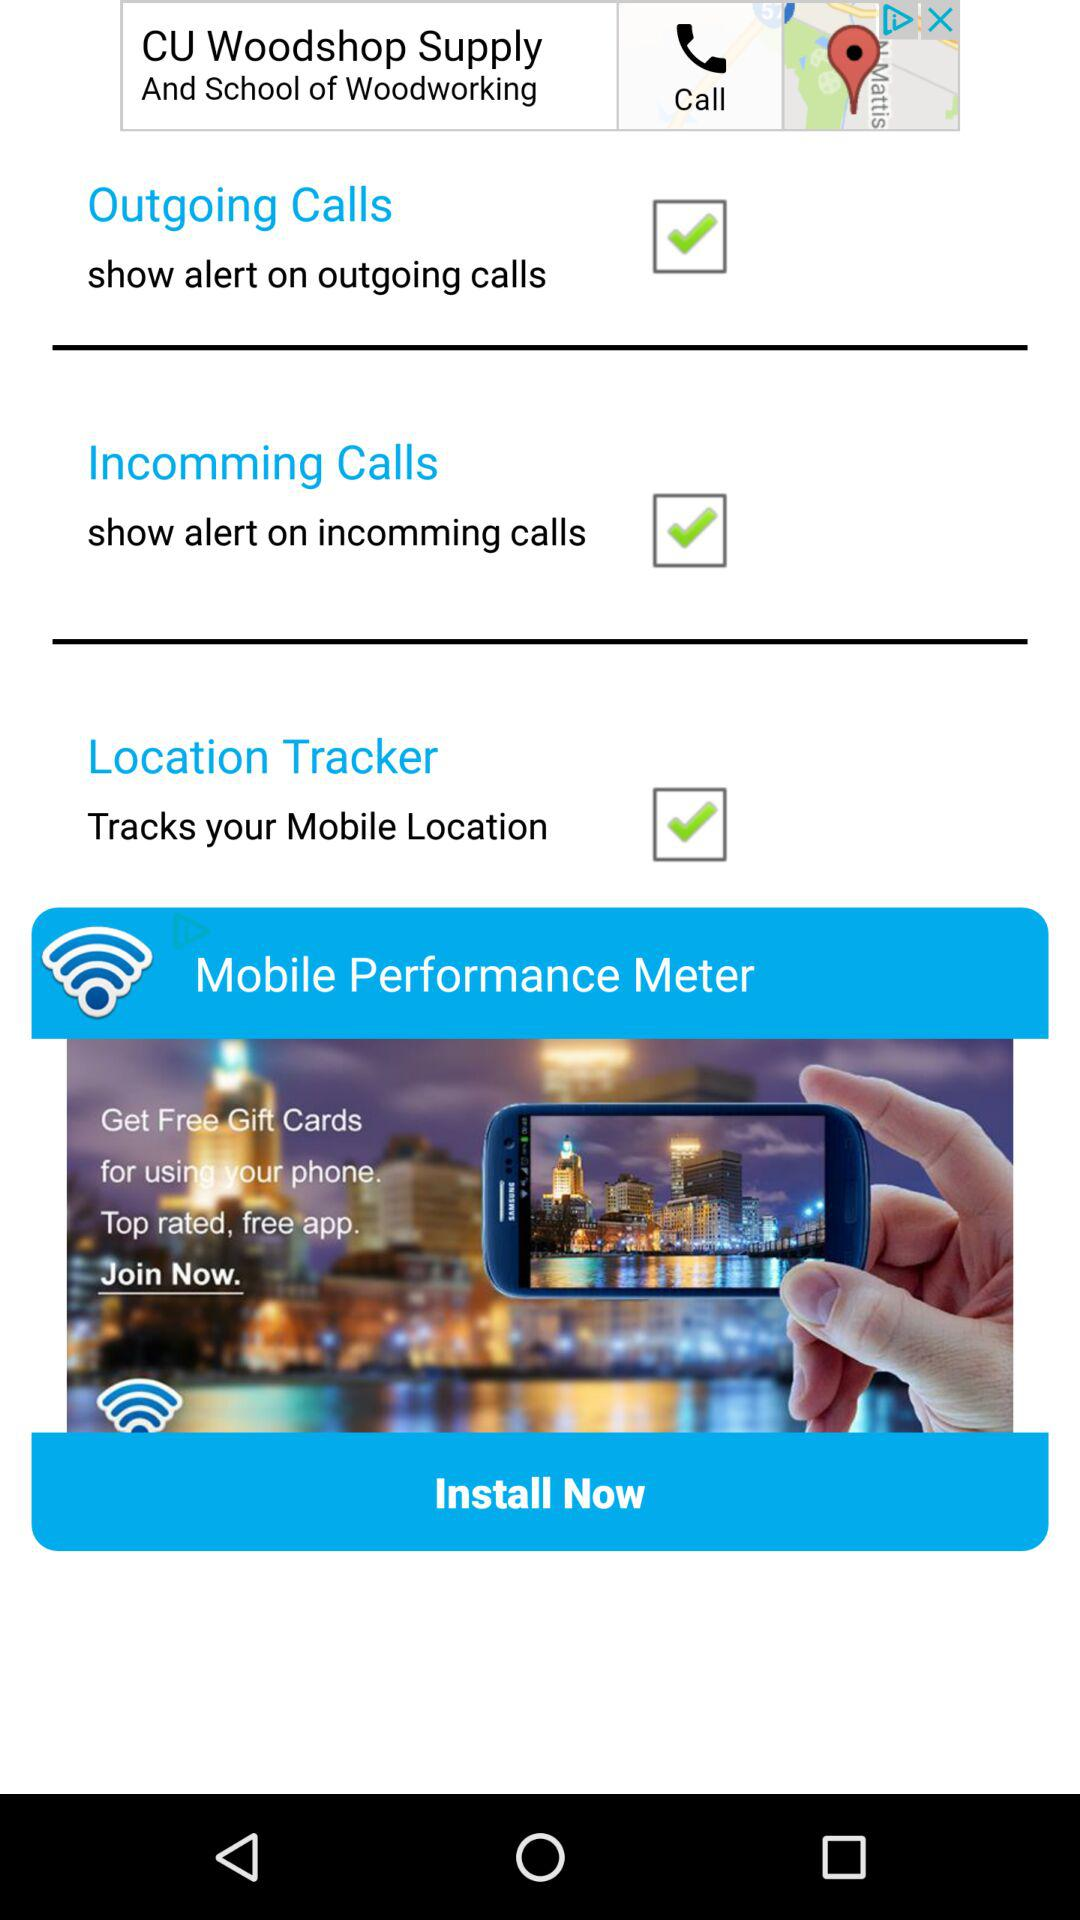How many checkboxes are on this screen?
Answer the question using a single word or phrase. 3 